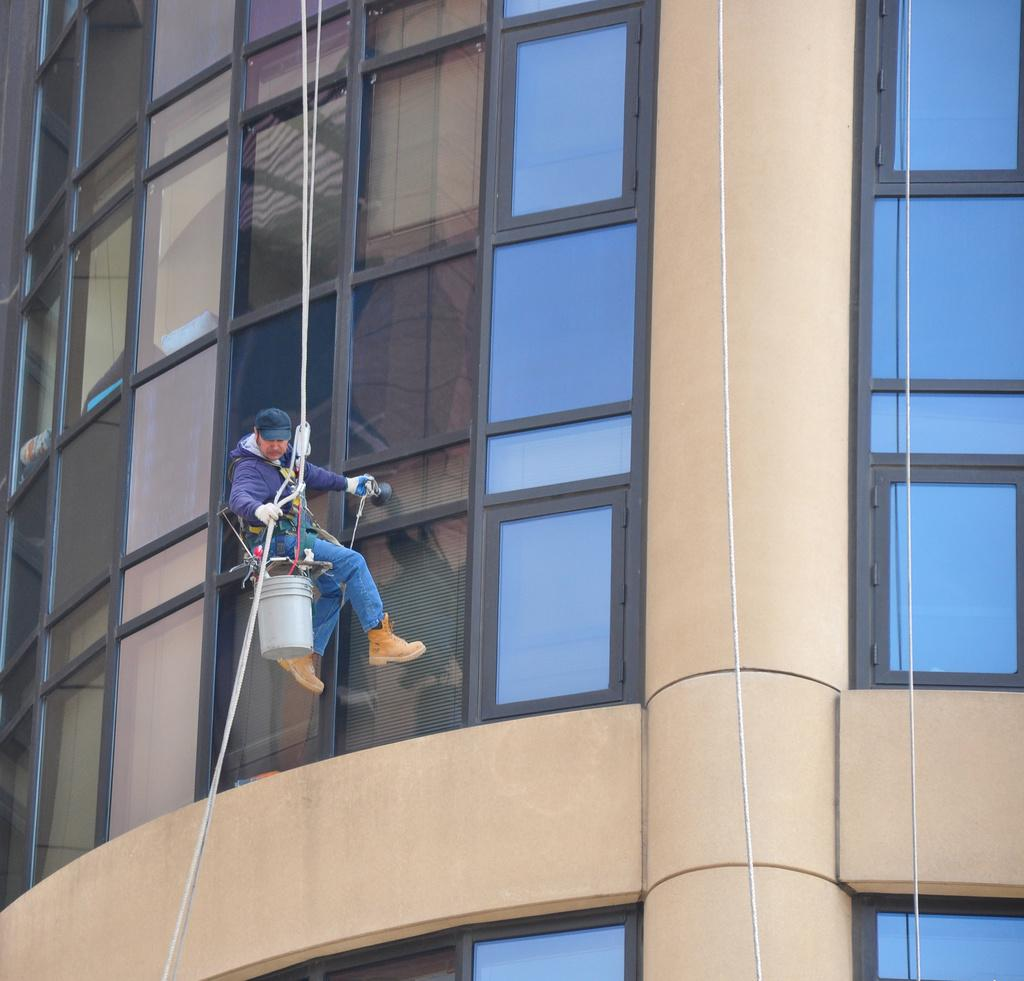What structure can be seen in the image? There is a building in the image. What is the person in the image doing? The person is cleaning the glass in the image. Are there any additional objects or features visible in the image? Yes, there are ropes visible in the image. What type of smoke can be seen coming from the building in the image? There is no smoke visible in the image; it only shows a person cleaning the glass and ropes. 